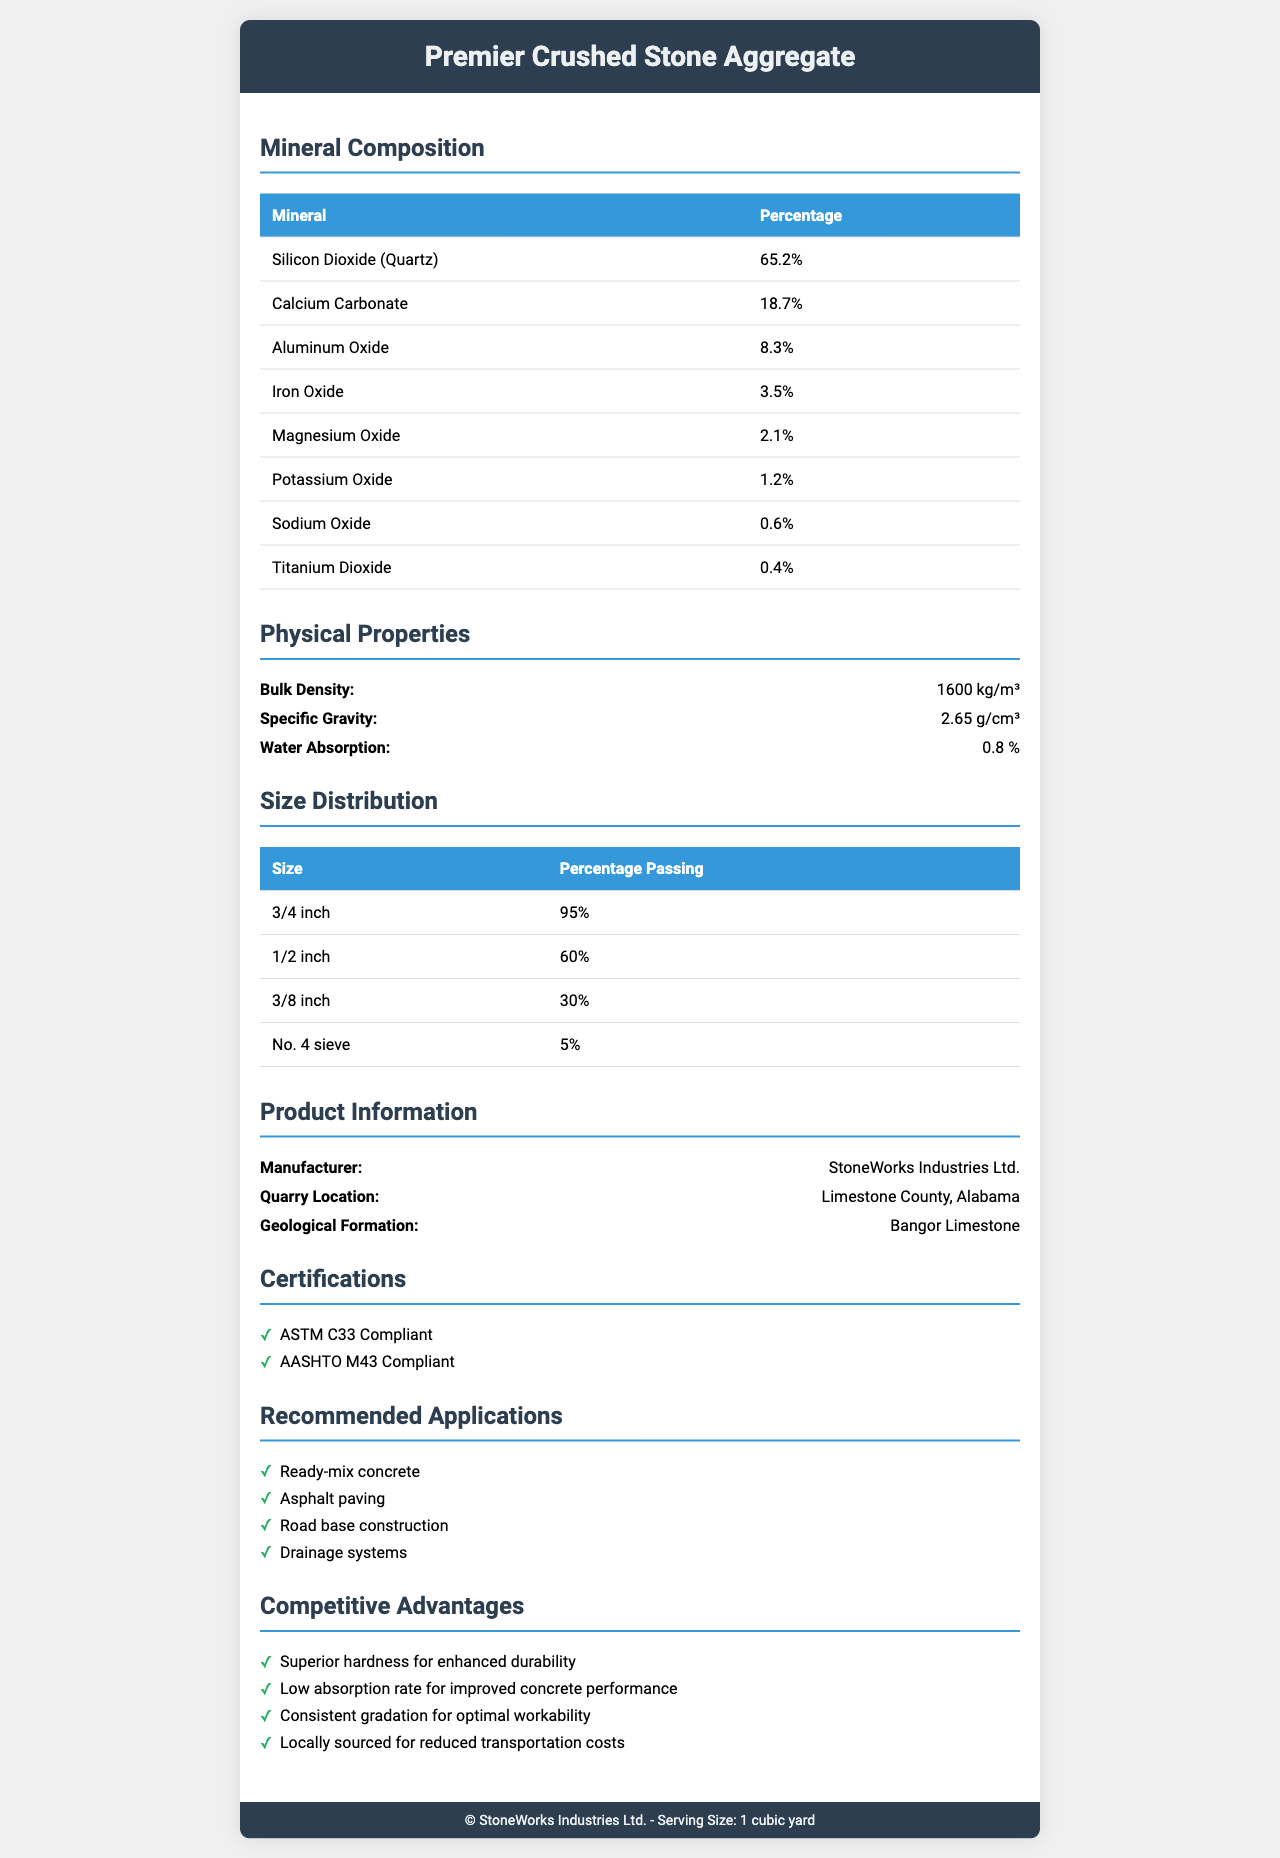what is the serving size of the Premier Crushed Stone Aggregate? The serving size is explicitly mentioned at the beginning of the document under the product name.
Answer: 1 cubic yard what is the main mineral in the composition of Premier Crushed Stone Aggregate? The mineral composition breakdown indicates that Silicon Dioxide (Quartz) makes up 65.2% of the aggregate, the highest percentage among the listed minerals.
Answer: Silicon Dioxide (Quartz) what is the bulk density of the Premier Crushed Stone Aggregate? The bulk density is provided in the "Physical Properties" section as 1600 kg/m³.
Answer: 1600 kg/m³ what applications are recommended for the Premier Crushed Stone Aggregate? The recommended applications are listed in the "Recommended Applications" section of the document.
Answer: Ready-mix concrete, Asphalt paving, Road base construction, Drainage systems what certifications does Premier Crushed Stone Aggregate have? The certifications are mentioned under the "Certifications" section.
Answer: ASTM C33 Compliant, AASHTO M43 Compliant what is the value of water absorption for this aggregate? The water absorption value is listed in the "Physical Properties" section as 0.8%.
Answer: 0.8% who is the manufacturer of the Premier Crushed Stone Aggregate? The manufacturer's name is mentioned in the "Product Information" section.
Answer: StoneWorks Industries Ltd. what size distribution percentage is least common in the Premier Crushed Stone Aggregate? The size distribution table shows that the No. 4 sieve size has the lowest percentage at 5%.
Answer: No. 4 sieve (5%) which of the following minerals is present in the smallest quantity in the aggregate? A. Potassium Oxide B. Sodium Oxide C. Titanium Dioxide D. Magnesium Oxide Titanium Dioxide, with a percentage of 0.4%, is the mineral present in the smallest quantity.
Answer: C what is the quarry location for the Premier Crushed Stone Aggregate? A. Limestone County, Alabama B. Granite County, Georgia C. Marble County, Texas The quarry location mentioned in the document is Limestone County, Alabama.
Answer: A is the aggregate compliant with ASTM C33 standards? (Yes/No) The document indicates that the Premier Crushed Stone Aggregate is ASTM C33 Compliant in the "Certifications" section.
Answer: Yes describe the main idea of the Premier Crushed Stone Aggregate document. The document encapsulates all pertinent details about the product, showcasing its features, benefits, and compliance standards to offer a comprehensive understanding of its properties and uses.
Answer: The document provides detailed information about the Premier Crushed Stone Aggregate, including its mineral composition, physical properties, size distribution, manufacturer, quarry location, certifications, recommended applications, and competitive advantages. what is the date of manufacture for the Premier Crushed Stone Aggregate? The document does not provide any information regarding the date of manufacture for the aggregate.
Answer: Not enough information 